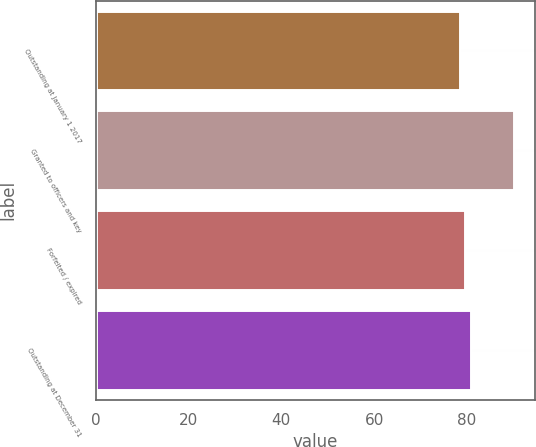Convert chart to OTSL. <chart><loc_0><loc_0><loc_500><loc_500><bar_chart><fcel>Outstanding at January 1 2017<fcel>Granted to officers and key<fcel>Forfeited / expired<fcel>Outstanding at December 31<nl><fcel>78.5<fcel>90.11<fcel>79.66<fcel>80.82<nl></chart> 